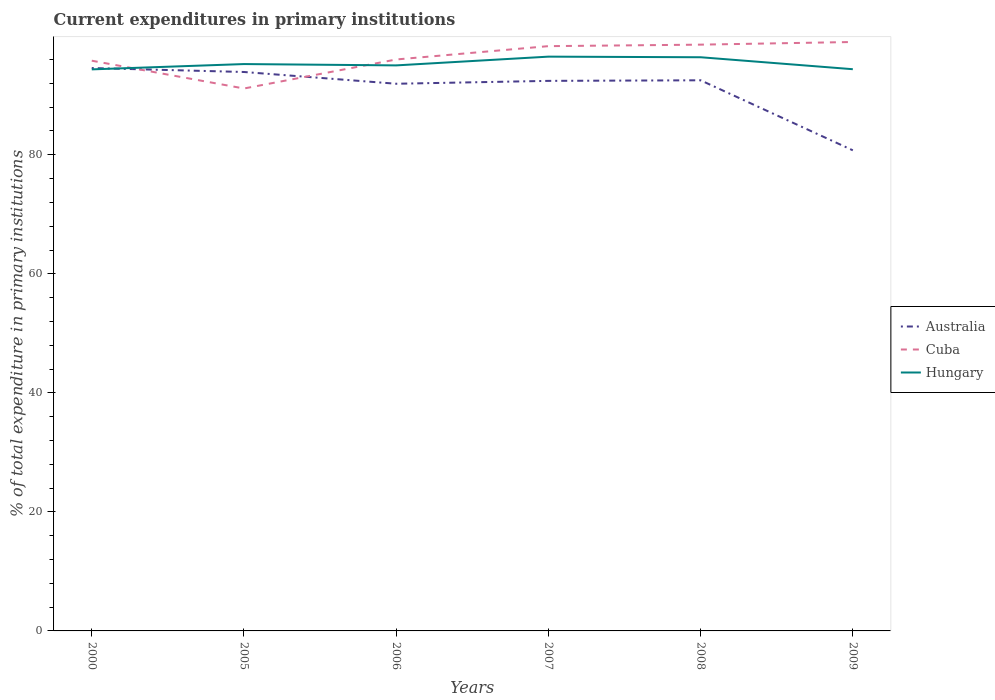Does the line corresponding to Cuba intersect with the line corresponding to Australia?
Your answer should be compact. Yes. Across all years, what is the maximum current expenditures in primary institutions in Australia?
Your answer should be very brief. 80.75. What is the total current expenditures in primary institutions in Cuba in the graph?
Your answer should be very brief. -2.24. What is the difference between the highest and the second highest current expenditures in primary institutions in Cuba?
Your answer should be very brief. 7.81. How many lines are there?
Offer a very short reply. 3. How many years are there in the graph?
Ensure brevity in your answer.  6. Are the values on the major ticks of Y-axis written in scientific E-notation?
Offer a terse response. No. Does the graph contain grids?
Provide a succinct answer. No. How many legend labels are there?
Ensure brevity in your answer.  3. What is the title of the graph?
Give a very brief answer. Current expenditures in primary institutions. Does "Central African Republic" appear as one of the legend labels in the graph?
Offer a terse response. No. What is the label or title of the Y-axis?
Your response must be concise. % of total expenditure in primary institutions. What is the % of total expenditure in primary institutions in Australia in 2000?
Your response must be concise. 94.58. What is the % of total expenditure in primary institutions in Cuba in 2000?
Keep it short and to the point. 95.81. What is the % of total expenditure in primary institutions of Hungary in 2000?
Offer a terse response. 94.35. What is the % of total expenditure in primary institutions in Australia in 2005?
Keep it short and to the point. 93.91. What is the % of total expenditure in primary institutions in Cuba in 2005?
Your response must be concise. 91.14. What is the % of total expenditure in primary institutions of Hungary in 2005?
Give a very brief answer. 95.25. What is the % of total expenditure in primary institutions of Australia in 2006?
Keep it short and to the point. 91.94. What is the % of total expenditure in primary institutions in Cuba in 2006?
Offer a terse response. 96.02. What is the % of total expenditure in primary institutions in Hungary in 2006?
Keep it short and to the point. 95.02. What is the % of total expenditure in primary institutions of Australia in 2007?
Ensure brevity in your answer.  92.42. What is the % of total expenditure in primary institutions of Cuba in 2007?
Your response must be concise. 98.26. What is the % of total expenditure in primary institutions of Hungary in 2007?
Keep it short and to the point. 96.49. What is the % of total expenditure in primary institutions in Australia in 2008?
Give a very brief answer. 92.52. What is the % of total expenditure in primary institutions in Cuba in 2008?
Your answer should be very brief. 98.51. What is the % of total expenditure in primary institutions of Hungary in 2008?
Make the answer very short. 96.39. What is the % of total expenditure in primary institutions of Australia in 2009?
Offer a very short reply. 80.75. What is the % of total expenditure in primary institutions in Cuba in 2009?
Give a very brief answer. 98.96. What is the % of total expenditure in primary institutions in Hungary in 2009?
Your response must be concise. 94.38. Across all years, what is the maximum % of total expenditure in primary institutions in Australia?
Ensure brevity in your answer.  94.58. Across all years, what is the maximum % of total expenditure in primary institutions in Cuba?
Offer a very short reply. 98.96. Across all years, what is the maximum % of total expenditure in primary institutions in Hungary?
Provide a short and direct response. 96.49. Across all years, what is the minimum % of total expenditure in primary institutions of Australia?
Ensure brevity in your answer.  80.75. Across all years, what is the minimum % of total expenditure in primary institutions of Cuba?
Provide a succinct answer. 91.14. Across all years, what is the minimum % of total expenditure in primary institutions of Hungary?
Your answer should be very brief. 94.35. What is the total % of total expenditure in primary institutions of Australia in the graph?
Provide a short and direct response. 546.13. What is the total % of total expenditure in primary institutions in Cuba in the graph?
Offer a very short reply. 578.69. What is the total % of total expenditure in primary institutions in Hungary in the graph?
Your response must be concise. 571.89. What is the difference between the % of total expenditure in primary institutions of Australia in 2000 and that in 2005?
Your answer should be very brief. 0.66. What is the difference between the % of total expenditure in primary institutions of Cuba in 2000 and that in 2005?
Make the answer very short. 4.67. What is the difference between the % of total expenditure in primary institutions of Hungary in 2000 and that in 2005?
Provide a short and direct response. -0.89. What is the difference between the % of total expenditure in primary institutions in Australia in 2000 and that in 2006?
Provide a short and direct response. 2.64. What is the difference between the % of total expenditure in primary institutions in Cuba in 2000 and that in 2006?
Offer a very short reply. -0.21. What is the difference between the % of total expenditure in primary institutions of Hungary in 2000 and that in 2006?
Offer a very short reply. -0.67. What is the difference between the % of total expenditure in primary institutions in Australia in 2000 and that in 2007?
Your response must be concise. 2.16. What is the difference between the % of total expenditure in primary institutions of Cuba in 2000 and that in 2007?
Provide a short and direct response. -2.45. What is the difference between the % of total expenditure in primary institutions in Hungary in 2000 and that in 2007?
Your answer should be compact. -2.14. What is the difference between the % of total expenditure in primary institutions in Australia in 2000 and that in 2008?
Provide a succinct answer. 2.06. What is the difference between the % of total expenditure in primary institutions of Cuba in 2000 and that in 2008?
Your answer should be compact. -2.7. What is the difference between the % of total expenditure in primary institutions of Hungary in 2000 and that in 2008?
Provide a succinct answer. -2.04. What is the difference between the % of total expenditure in primary institutions of Australia in 2000 and that in 2009?
Make the answer very short. 13.82. What is the difference between the % of total expenditure in primary institutions in Cuba in 2000 and that in 2009?
Make the answer very short. -3.14. What is the difference between the % of total expenditure in primary institutions in Hungary in 2000 and that in 2009?
Give a very brief answer. -0.03. What is the difference between the % of total expenditure in primary institutions in Australia in 2005 and that in 2006?
Your response must be concise. 1.98. What is the difference between the % of total expenditure in primary institutions in Cuba in 2005 and that in 2006?
Ensure brevity in your answer.  -4.87. What is the difference between the % of total expenditure in primary institutions in Hungary in 2005 and that in 2006?
Your answer should be very brief. 0.22. What is the difference between the % of total expenditure in primary institutions in Australia in 2005 and that in 2007?
Offer a very short reply. 1.49. What is the difference between the % of total expenditure in primary institutions of Cuba in 2005 and that in 2007?
Your response must be concise. -7.12. What is the difference between the % of total expenditure in primary institutions in Hungary in 2005 and that in 2007?
Provide a short and direct response. -1.25. What is the difference between the % of total expenditure in primary institutions in Australia in 2005 and that in 2008?
Make the answer very short. 1.39. What is the difference between the % of total expenditure in primary institutions in Cuba in 2005 and that in 2008?
Give a very brief answer. -7.37. What is the difference between the % of total expenditure in primary institutions of Hungary in 2005 and that in 2008?
Make the answer very short. -1.15. What is the difference between the % of total expenditure in primary institutions of Australia in 2005 and that in 2009?
Provide a short and direct response. 13.16. What is the difference between the % of total expenditure in primary institutions of Cuba in 2005 and that in 2009?
Ensure brevity in your answer.  -7.81. What is the difference between the % of total expenditure in primary institutions in Hungary in 2005 and that in 2009?
Offer a very short reply. 0.87. What is the difference between the % of total expenditure in primary institutions in Australia in 2006 and that in 2007?
Provide a succinct answer. -0.48. What is the difference between the % of total expenditure in primary institutions of Cuba in 2006 and that in 2007?
Make the answer very short. -2.24. What is the difference between the % of total expenditure in primary institutions of Hungary in 2006 and that in 2007?
Provide a short and direct response. -1.47. What is the difference between the % of total expenditure in primary institutions of Australia in 2006 and that in 2008?
Provide a short and direct response. -0.58. What is the difference between the % of total expenditure in primary institutions in Cuba in 2006 and that in 2008?
Your response must be concise. -2.49. What is the difference between the % of total expenditure in primary institutions in Hungary in 2006 and that in 2008?
Provide a short and direct response. -1.37. What is the difference between the % of total expenditure in primary institutions in Australia in 2006 and that in 2009?
Provide a succinct answer. 11.18. What is the difference between the % of total expenditure in primary institutions in Cuba in 2006 and that in 2009?
Your answer should be very brief. -2.94. What is the difference between the % of total expenditure in primary institutions in Hungary in 2006 and that in 2009?
Offer a terse response. 0.64. What is the difference between the % of total expenditure in primary institutions in Australia in 2007 and that in 2008?
Make the answer very short. -0.1. What is the difference between the % of total expenditure in primary institutions in Cuba in 2007 and that in 2008?
Provide a short and direct response. -0.25. What is the difference between the % of total expenditure in primary institutions of Hungary in 2007 and that in 2008?
Offer a very short reply. 0.1. What is the difference between the % of total expenditure in primary institutions of Australia in 2007 and that in 2009?
Make the answer very short. 11.67. What is the difference between the % of total expenditure in primary institutions of Cuba in 2007 and that in 2009?
Make the answer very short. -0.7. What is the difference between the % of total expenditure in primary institutions in Hungary in 2007 and that in 2009?
Your answer should be very brief. 2.11. What is the difference between the % of total expenditure in primary institutions in Australia in 2008 and that in 2009?
Keep it short and to the point. 11.77. What is the difference between the % of total expenditure in primary institutions in Cuba in 2008 and that in 2009?
Provide a succinct answer. -0.45. What is the difference between the % of total expenditure in primary institutions of Hungary in 2008 and that in 2009?
Your answer should be very brief. 2.01. What is the difference between the % of total expenditure in primary institutions in Australia in 2000 and the % of total expenditure in primary institutions in Cuba in 2005?
Your response must be concise. 3.44. What is the difference between the % of total expenditure in primary institutions in Australia in 2000 and the % of total expenditure in primary institutions in Hungary in 2005?
Offer a terse response. -0.67. What is the difference between the % of total expenditure in primary institutions of Cuba in 2000 and the % of total expenditure in primary institutions of Hungary in 2005?
Ensure brevity in your answer.  0.56. What is the difference between the % of total expenditure in primary institutions in Australia in 2000 and the % of total expenditure in primary institutions in Cuba in 2006?
Provide a short and direct response. -1.44. What is the difference between the % of total expenditure in primary institutions in Australia in 2000 and the % of total expenditure in primary institutions in Hungary in 2006?
Keep it short and to the point. -0.44. What is the difference between the % of total expenditure in primary institutions of Cuba in 2000 and the % of total expenditure in primary institutions of Hungary in 2006?
Your answer should be compact. 0.79. What is the difference between the % of total expenditure in primary institutions of Australia in 2000 and the % of total expenditure in primary institutions of Cuba in 2007?
Offer a very short reply. -3.68. What is the difference between the % of total expenditure in primary institutions of Australia in 2000 and the % of total expenditure in primary institutions of Hungary in 2007?
Ensure brevity in your answer.  -1.91. What is the difference between the % of total expenditure in primary institutions in Cuba in 2000 and the % of total expenditure in primary institutions in Hungary in 2007?
Your answer should be very brief. -0.68. What is the difference between the % of total expenditure in primary institutions in Australia in 2000 and the % of total expenditure in primary institutions in Cuba in 2008?
Give a very brief answer. -3.93. What is the difference between the % of total expenditure in primary institutions of Australia in 2000 and the % of total expenditure in primary institutions of Hungary in 2008?
Your answer should be very brief. -1.81. What is the difference between the % of total expenditure in primary institutions in Cuba in 2000 and the % of total expenditure in primary institutions in Hungary in 2008?
Keep it short and to the point. -0.58. What is the difference between the % of total expenditure in primary institutions in Australia in 2000 and the % of total expenditure in primary institutions in Cuba in 2009?
Ensure brevity in your answer.  -4.38. What is the difference between the % of total expenditure in primary institutions of Australia in 2000 and the % of total expenditure in primary institutions of Hungary in 2009?
Offer a terse response. 0.2. What is the difference between the % of total expenditure in primary institutions in Cuba in 2000 and the % of total expenditure in primary institutions in Hungary in 2009?
Offer a terse response. 1.43. What is the difference between the % of total expenditure in primary institutions in Australia in 2005 and the % of total expenditure in primary institutions in Cuba in 2006?
Provide a short and direct response. -2.1. What is the difference between the % of total expenditure in primary institutions in Australia in 2005 and the % of total expenditure in primary institutions in Hungary in 2006?
Your response must be concise. -1.11. What is the difference between the % of total expenditure in primary institutions in Cuba in 2005 and the % of total expenditure in primary institutions in Hungary in 2006?
Your answer should be compact. -3.88. What is the difference between the % of total expenditure in primary institutions of Australia in 2005 and the % of total expenditure in primary institutions of Cuba in 2007?
Give a very brief answer. -4.34. What is the difference between the % of total expenditure in primary institutions in Australia in 2005 and the % of total expenditure in primary institutions in Hungary in 2007?
Offer a terse response. -2.58. What is the difference between the % of total expenditure in primary institutions in Cuba in 2005 and the % of total expenditure in primary institutions in Hungary in 2007?
Keep it short and to the point. -5.35. What is the difference between the % of total expenditure in primary institutions in Australia in 2005 and the % of total expenditure in primary institutions in Cuba in 2008?
Offer a terse response. -4.59. What is the difference between the % of total expenditure in primary institutions of Australia in 2005 and the % of total expenditure in primary institutions of Hungary in 2008?
Provide a short and direct response. -2.48. What is the difference between the % of total expenditure in primary institutions in Cuba in 2005 and the % of total expenditure in primary institutions in Hungary in 2008?
Give a very brief answer. -5.25. What is the difference between the % of total expenditure in primary institutions in Australia in 2005 and the % of total expenditure in primary institutions in Cuba in 2009?
Offer a very short reply. -5.04. What is the difference between the % of total expenditure in primary institutions in Australia in 2005 and the % of total expenditure in primary institutions in Hungary in 2009?
Your answer should be compact. -0.47. What is the difference between the % of total expenditure in primary institutions in Cuba in 2005 and the % of total expenditure in primary institutions in Hungary in 2009?
Your response must be concise. -3.24. What is the difference between the % of total expenditure in primary institutions in Australia in 2006 and the % of total expenditure in primary institutions in Cuba in 2007?
Provide a short and direct response. -6.32. What is the difference between the % of total expenditure in primary institutions in Australia in 2006 and the % of total expenditure in primary institutions in Hungary in 2007?
Offer a terse response. -4.55. What is the difference between the % of total expenditure in primary institutions in Cuba in 2006 and the % of total expenditure in primary institutions in Hungary in 2007?
Your response must be concise. -0.48. What is the difference between the % of total expenditure in primary institutions in Australia in 2006 and the % of total expenditure in primary institutions in Cuba in 2008?
Make the answer very short. -6.57. What is the difference between the % of total expenditure in primary institutions of Australia in 2006 and the % of total expenditure in primary institutions of Hungary in 2008?
Offer a terse response. -4.45. What is the difference between the % of total expenditure in primary institutions of Cuba in 2006 and the % of total expenditure in primary institutions of Hungary in 2008?
Your answer should be compact. -0.38. What is the difference between the % of total expenditure in primary institutions in Australia in 2006 and the % of total expenditure in primary institutions in Cuba in 2009?
Make the answer very short. -7.02. What is the difference between the % of total expenditure in primary institutions in Australia in 2006 and the % of total expenditure in primary institutions in Hungary in 2009?
Ensure brevity in your answer.  -2.44. What is the difference between the % of total expenditure in primary institutions in Cuba in 2006 and the % of total expenditure in primary institutions in Hungary in 2009?
Your answer should be compact. 1.63. What is the difference between the % of total expenditure in primary institutions of Australia in 2007 and the % of total expenditure in primary institutions of Cuba in 2008?
Offer a terse response. -6.09. What is the difference between the % of total expenditure in primary institutions of Australia in 2007 and the % of total expenditure in primary institutions of Hungary in 2008?
Give a very brief answer. -3.97. What is the difference between the % of total expenditure in primary institutions of Cuba in 2007 and the % of total expenditure in primary institutions of Hungary in 2008?
Your response must be concise. 1.87. What is the difference between the % of total expenditure in primary institutions of Australia in 2007 and the % of total expenditure in primary institutions of Cuba in 2009?
Give a very brief answer. -6.53. What is the difference between the % of total expenditure in primary institutions in Australia in 2007 and the % of total expenditure in primary institutions in Hungary in 2009?
Provide a succinct answer. -1.96. What is the difference between the % of total expenditure in primary institutions in Cuba in 2007 and the % of total expenditure in primary institutions in Hungary in 2009?
Offer a terse response. 3.88. What is the difference between the % of total expenditure in primary institutions in Australia in 2008 and the % of total expenditure in primary institutions in Cuba in 2009?
Offer a terse response. -6.43. What is the difference between the % of total expenditure in primary institutions of Australia in 2008 and the % of total expenditure in primary institutions of Hungary in 2009?
Ensure brevity in your answer.  -1.86. What is the difference between the % of total expenditure in primary institutions of Cuba in 2008 and the % of total expenditure in primary institutions of Hungary in 2009?
Provide a short and direct response. 4.13. What is the average % of total expenditure in primary institutions of Australia per year?
Your answer should be compact. 91.02. What is the average % of total expenditure in primary institutions in Cuba per year?
Give a very brief answer. 96.45. What is the average % of total expenditure in primary institutions in Hungary per year?
Offer a terse response. 95.32. In the year 2000, what is the difference between the % of total expenditure in primary institutions in Australia and % of total expenditure in primary institutions in Cuba?
Give a very brief answer. -1.23. In the year 2000, what is the difference between the % of total expenditure in primary institutions in Australia and % of total expenditure in primary institutions in Hungary?
Give a very brief answer. 0.23. In the year 2000, what is the difference between the % of total expenditure in primary institutions in Cuba and % of total expenditure in primary institutions in Hungary?
Your response must be concise. 1.46. In the year 2005, what is the difference between the % of total expenditure in primary institutions in Australia and % of total expenditure in primary institutions in Cuba?
Provide a short and direct response. 2.77. In the year 2005, what is the difference between the % of total expenditure in primary institutions of Australia and % of total expenditure in primary institutions of Hungary?
Keep it short and to the point. -1.33. In the year 2005, what is the difference between the % of total expenditure in primary institutions in Cuba and % of total expenditure in primary institutions in Hungary?
Your response must be concise. -4.11. In the year 2006, what is the difference between the % of total expenditure in primary institutions in Australia and % of total expenditure in primary institutions in Cuba?
Ensure brevity in your answer.  -4.08. In the year 2006, what is the difference between the % of total expenditure in primary institutions of Australia and % of total expenditure in primary institutions of Hungary?
Make the answer very short. -3.08. In the year 2006, what is the difference between the % of total expenditure in primary institutions of Cuba and % of total expenditure in primary institutions of Hungary?
Offer a very short reply. 0.99. In the year 2007, what is the difference between the % of total expenditure in primary institutions of Australia and % of total expenditure in primary institutions of Cuba?
Offer a terse response. -5.83. In the year 2007, what is the difference between the % of total expenditure in primary institutions in Australia and % of total expenditure in primary institutions in Hungary?
Your answer should be very brief. -4.07. In the year 2007, what is the difference between the % of total expenditure in primary institutions in Cuba and % of total expenditure in primary institutions in Hungary?
Offer a terse response. 1.76. In the year 2008, what is the difference between the % of total expenditure in primary institutions in Australia and % of total expenditure in primary institutions in Cuba?
Keep it short and to the point. -5.99. In the year 2008, what is the difference between the % of total expenditure in primary institutions of Australia and % of total expenditure in primary institutions of Hungary?
Ensure brevity in your answer.  -3.87. In the year 2008, what is the difference between the % of total expenditure in primary institutions of Cuba and % of total expenditure in primary institutions of Hungary?
Offer a very short reply. 2.12. In the year 2009, what is the difference between the % of total expenditure in primary institutions in Australia and % of total expenditure in primary institutions in Cuba?
Offer a terse response. -18.2. In the year 2009, what is the difference between the % of total expenditure in primary institutions in Australia and % of total expenditure in primary institutions in Hungary?
Provide a short and direct response. -13.63. In the year 2009, what is the difference between the % of total expenditure in primary institutions in Cuba and % of total expenditure in primary institutions in Hungary?
Ensure brevity in your answer.  4.57. What is the ratio of the % of total expenditure in primary institutions in Australia in 2000 to that in 2005?
Offer a very short reply. 1.01. What is the ratio of the % of total expenditure in primary institutions in Cuba in 2000 to that in 2005?
Your response must be concise. 1.05. What is the ratio of the % of total expenditure in primary institutions of Hungary in 2000 to that in 2005?
Offer a terse response. 0.99. What is the ratio of the % of total expenditure in primary institutions in Australia in 2000 to that in 2006?
Ensure brevity in your answer.  1.03. What is the ratio of the % of total expenditure in primary institutions in Cuba in 2000 to that in 2006?
Your answer should be compact. 1. What is the ratio of the % of total expenditure in primary institutions in Australia in 2000 to that in 2007?
Give a very brief answer. 1.02. What is the ratio of the % of total expenditure in primary institutions in Cuba in 2000 to that in 2007?
Provide a short and direct response. 0.98. What is the ratio of the % of total expenditure in primary institutions in Hungary in 2000 to that in 2007?
Your answer should be compact. 0.98. What is the ratio of the % of total expenditure in primary institutions of Australia in 2000 to that in 2008?
Keep it short and to the point. 1.02. What is the ratio of the % of total expenditure in primary institutions in Cuba in 2000 to that in 2008?
Offer a terse response. 0.97. What is the ratio of the % of total expenditure in primary institutions of Hungary in 2000 to that in 2008?
Your response must be concise. 0.98. What is the ratio of the % of total expenditure in primary institutions of Australia in 2000 to that in 2009?
Keep it short and to the point. 1.17. What is the ratio of the % of total expenditure in primary institutions in Cuba in 2000 to that in 2009?
Ensure brevity in your answer.  0.97. What is the ratio of the % of total expenditure in primary institutions in Hungary in 2000 to that in 2009?
Make the answer very short. 1. What is the ratio of the % of total expenditure in primary institutions of Australia in 2005 to that in 2006?
Provide a short and direct response. 1.02. What is the ratio of the % of total expenditure in primary institutions in Cuba in 2005 to that in 2006?
Make the answer very short. 0.95. What is the ratio of the % of total expenditure in primary institutions of Hungary in 2005 to that in 2006?
Your answer should be very brief. 1. What is the ratio of the % of total expenditure in primary institutions in Australia in 2005 to that in 2007?
Offer a terse response. 1.02. What is the ratio of the % of total expenditure in primary institutions of Cuba in 2005 to that in 2007?
Make the answer very short. 0.93. What is the ratio of the % of total expenditure in primary institutions in Hungary in 2005 to that in 2007?
Give a very brief answer. 0.99. What is the ratio of the % of total expenditure in primary institutions of Australia in 2005 to that in 2008?
Keep it short and to the point. 1.02. What is the ratio of the % of total expenditure in primary institutions in Cuba in 2005 to that in 2008?
Ensure brevity in your answer.  0.93. What is the ratio of the % of total expenditure in primary institutions of Australia in 2005 to that in 2009?
Your answer should be compact. 1.16. What is the ratio of the % of total expenditure in primary institutions of Cuba in 2005 to that in 2009?
Keep it short and to the point. 0.92. What is the ratio of the % of total expenditure in primary institutions in Hungary in 2005 to that in 2009?
Offer a very short reply. 1.01. What is the ratio of the % of total expenditure in primary institutions of Australia in 2006 to that in 2007?
Offer a terse response. 0.99. What is the ratio of the % of total expenditure in primary institutions of Cuba in 2006 to that in 2007?
Your answer should be very brief. 0.98. What is the ratio of the % of total expenditure in primary institutions of Cuba in 2006 to that in 2008?
Provide a succinct answer. 0.97. What is the ratio of the % of total expenditure in primary institutions in Hungary in 2006 to that in 2008?
Keep it short and to the point. 0.99. What is the ratio of the % of total expenditure in primary institutions of Australia in 2006 to that in 2009?
Ensure brevity in your answer.  1.14. What is the ratio of the % of total expenditure in primary institutions of Cuba in 2006 to that in 2009?
Keep it short and to the point. 0.97. What is the ratio of the % of total expenditure in primary institutions in Hungary in 2006 to that in 2009?
Your answer should be compact. 1.01. What is the ratio of the % of total expenditure in primary institutions of Australia in 2007 to that in 2008?
Your answer should be very brief. 1. What is the ratio of the % of total expenditure in primary institutions of Cuba in 2007 to that in 2008?
Your answer should be compact. 1. What is the ratio of the % of total expenditure in primary institutions in Hungary in 2007 to that in 2008?
Your answer should be compact. 1. What is the ratio of the % of total expenditure in primary institutions in Australia in 2007 to that in 2009?
Offer a very short reply. 1.14. What is the ratio of the % of total expenditure in primary institutions of Cuba in 2007 to that in 2009?
Offer a terse response. 0.99. What is the ratio of the % of total expenditure in primary institutions in Hungary in 2007 to that in 2009?
Offer a terse response. 1.02. What is the ratio of the % of total expenditure in primary institutions of Australia in 2008 to that in 2009?
Keep it short and to the point. 1.15. What is the ratio of the % of total expenditure in primary institutions in Cuba in 2008 to that in 2009?
Your answer should be compact. 1. What is the ratio of the % of total expenditure in primary institutions in Hungary in 2008 to that in 2009?
Offer a terse response. 1.02. What is the difference between the highest and the second highest % of total expenditure in primary institutions of Australia?
Give a very brief answer. 0.66. What is the difference between the highest and the second highest % of total expenditure in primary institutions in Cuba?
Your response must be concise. 0.45. What is the difference between the highest and the second highest % of total expenditure in primary institutions of Hungary?
Offer a very short reply. 0.1. What is the difference between the highest and the lowest % of total expenditure in primary institutions of Australia?
Provide a short and direct response. 13.82. What is the difference between the highest and the lowest % of total expenditure in primary institutions in Cuba?
Make the answer very short. 7.81. What is the difference between the highest and the lowest % of total expenditure in primary institutions of Hungary?
Provide a short and direct response. 2.14. 